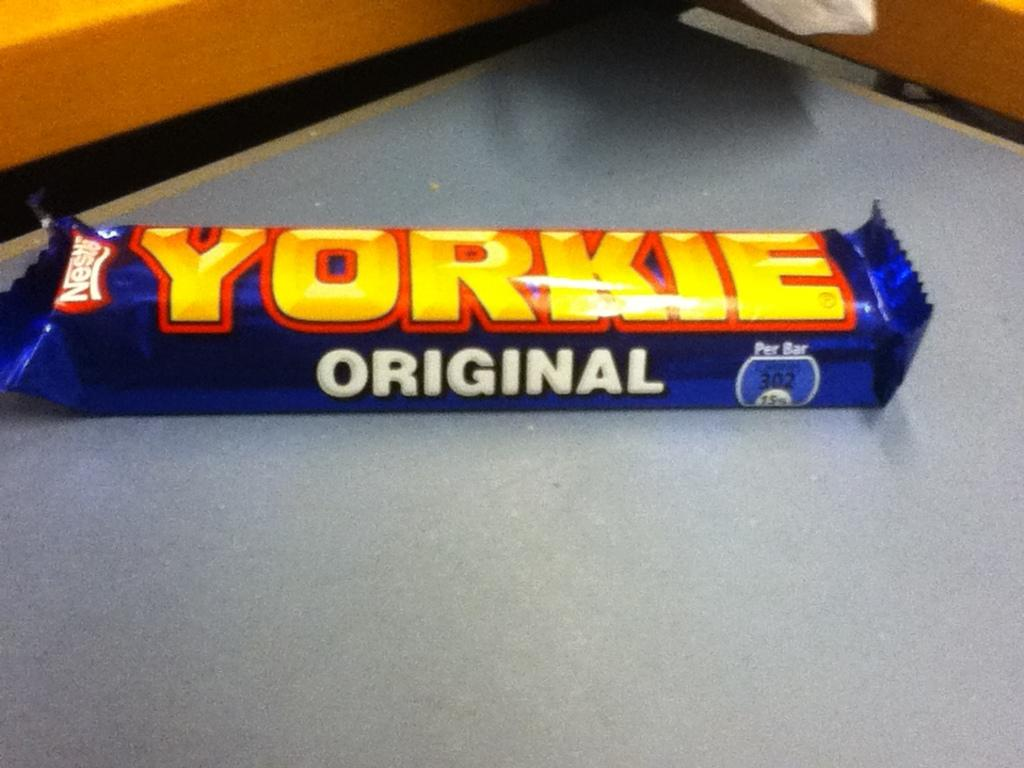<image>
Give a short and clear explanation of the subsequent image. The candy bar Yorkie Original is made by Nestle. 